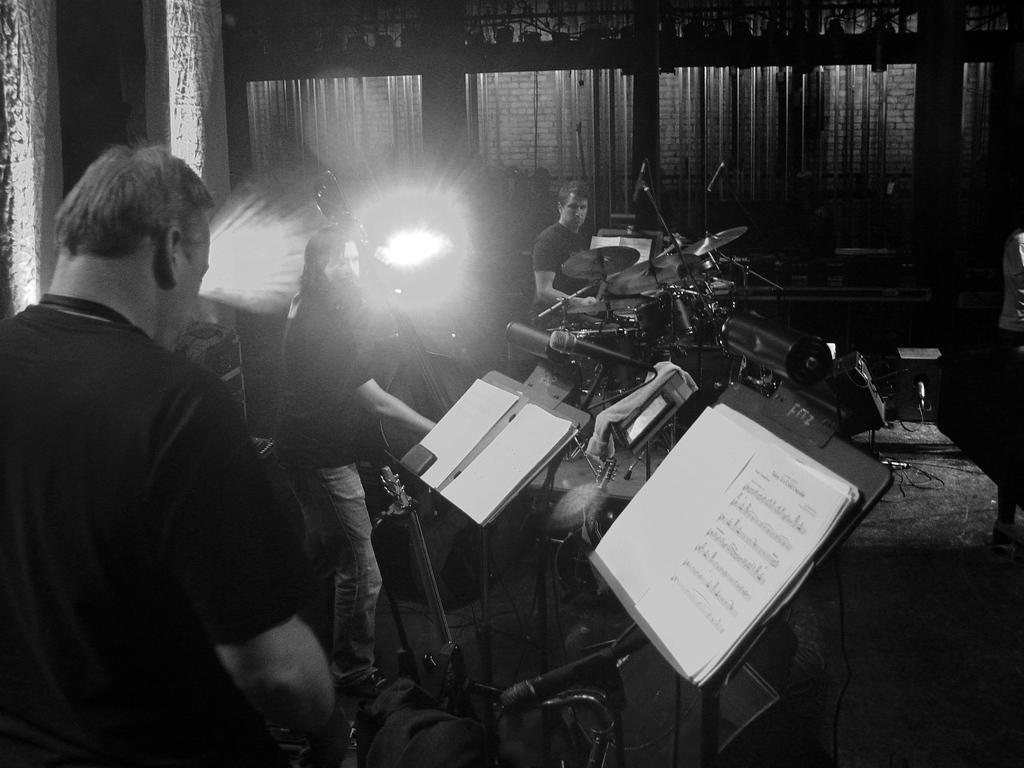Could you give a brief overview of what you see in this image? Three men are playing music on a stage. Of them a man is playing drums and other is playing cello. 